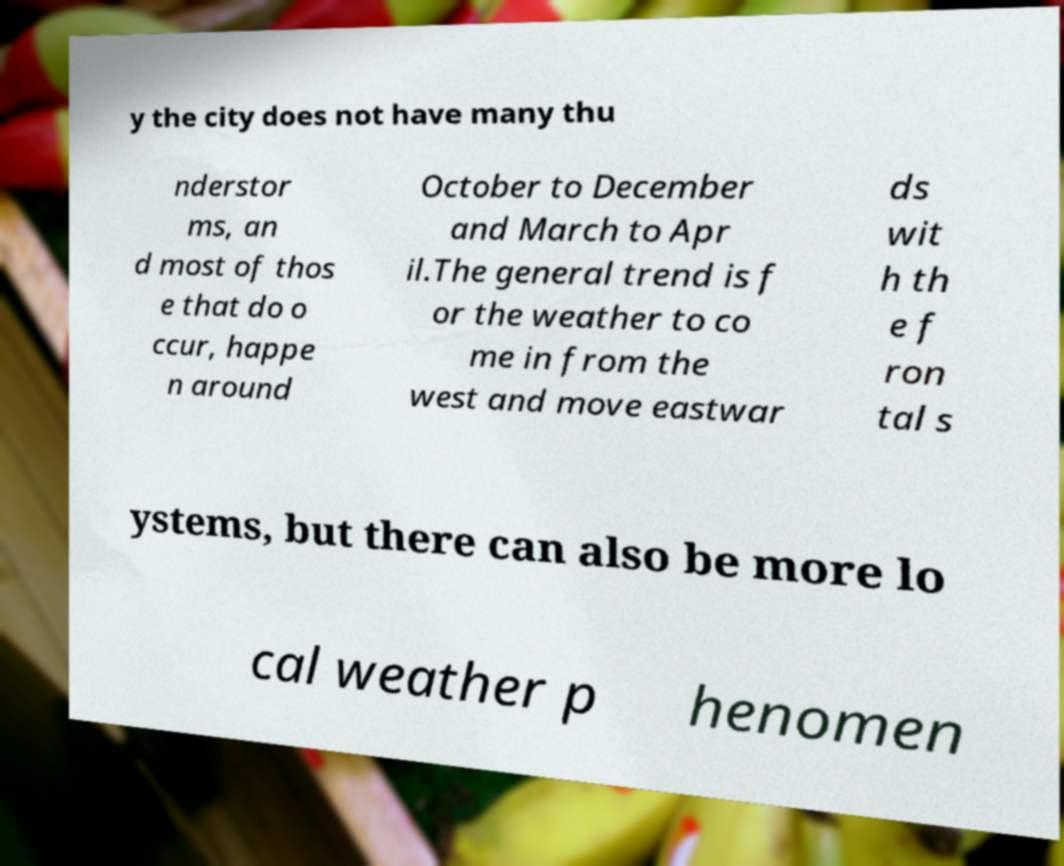There's text embedded in this image that I need extracted. Can you transcribe it verbatim? y the city does not have many thu nderstor ms, an d most of thos e that do o ccur, happe n around October to December and March to Apr il.The general trend is f or the weather to co me in from the west and move eastwar ds wit h th e f ron tal s ystems, but there can also be more lo cal weather p henomen 